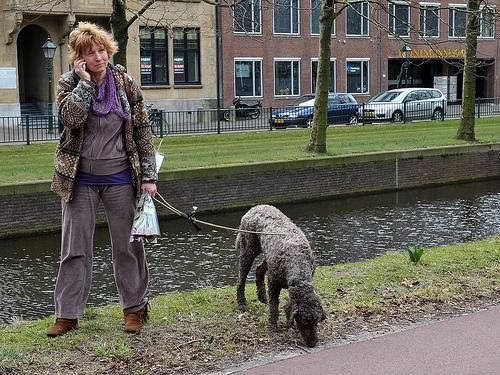How many lamp posts are to the left of the person?
Give a very brief answer. 1. 